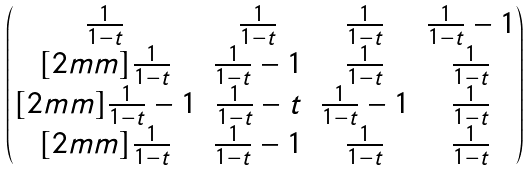<formula> <loc_0><loc_0><loc_500><loc_500>\begin{pmatrix} \frac { 1 } { 1 - t } & \frac { 1 } { 1 - t } & \frac { 1 } { 1 - t } & \frac { 1 } { 1 - t } - 1 \\ [ 2 m m ] \frac { 1 } { 1 - t } & \frac { 1 } { 1 - t } - 1 & \frac { 1 } { 1 - t } & \frac { 1 } { 1 - t } \\ [ 2 m m ] \frac { 1 } { 1 - t } - 1 & \frac { 1 } { 1 - t } - t & \frac { 1 } { 1 - t } - 1 & \frac { 1 } { 1 - t } \\ [ 2 m m ] \frac { 1 } { 1 - t } & \frac { 1 } { 1 - t } - 1 & \frac { 1 } { 1 - t } & \frac { 1 } { 1 - t } \end{pmatrix}</formula> 